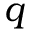Convert formula to latex. <formula><loc_0><loc_0><loc_500><loc_500>q</formula> 